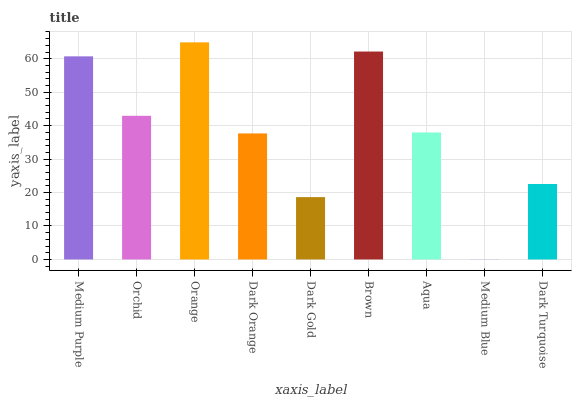Is Medium Blue the minimum?
Answer yes or no. Yes. Is Orange the maximum?
Answer yes or no. Yes. Is Orchid the minimum?
Answer yes or no. No. Is Orchid the maximum?
Answer yes or no. No. Is Medium Purple greater than Orchid?
Answer yes or no. Yes. Is Orchid less than Medium Purple?
Answer yes or no. Yes. Is Orchid greater than Medium Purple?
Answer yes or no. No. Is Medium Purple less than Orchid?
Answer yes or no. No. Is Aqua the high median?
Answer yes or no. Yes. Is Aqua the low median?
Answer yes or no. Yes. Is Dark Turquoise the high median?
Answer yes or no. No. Is Orchid the low median?
Answer yes or no. No. 